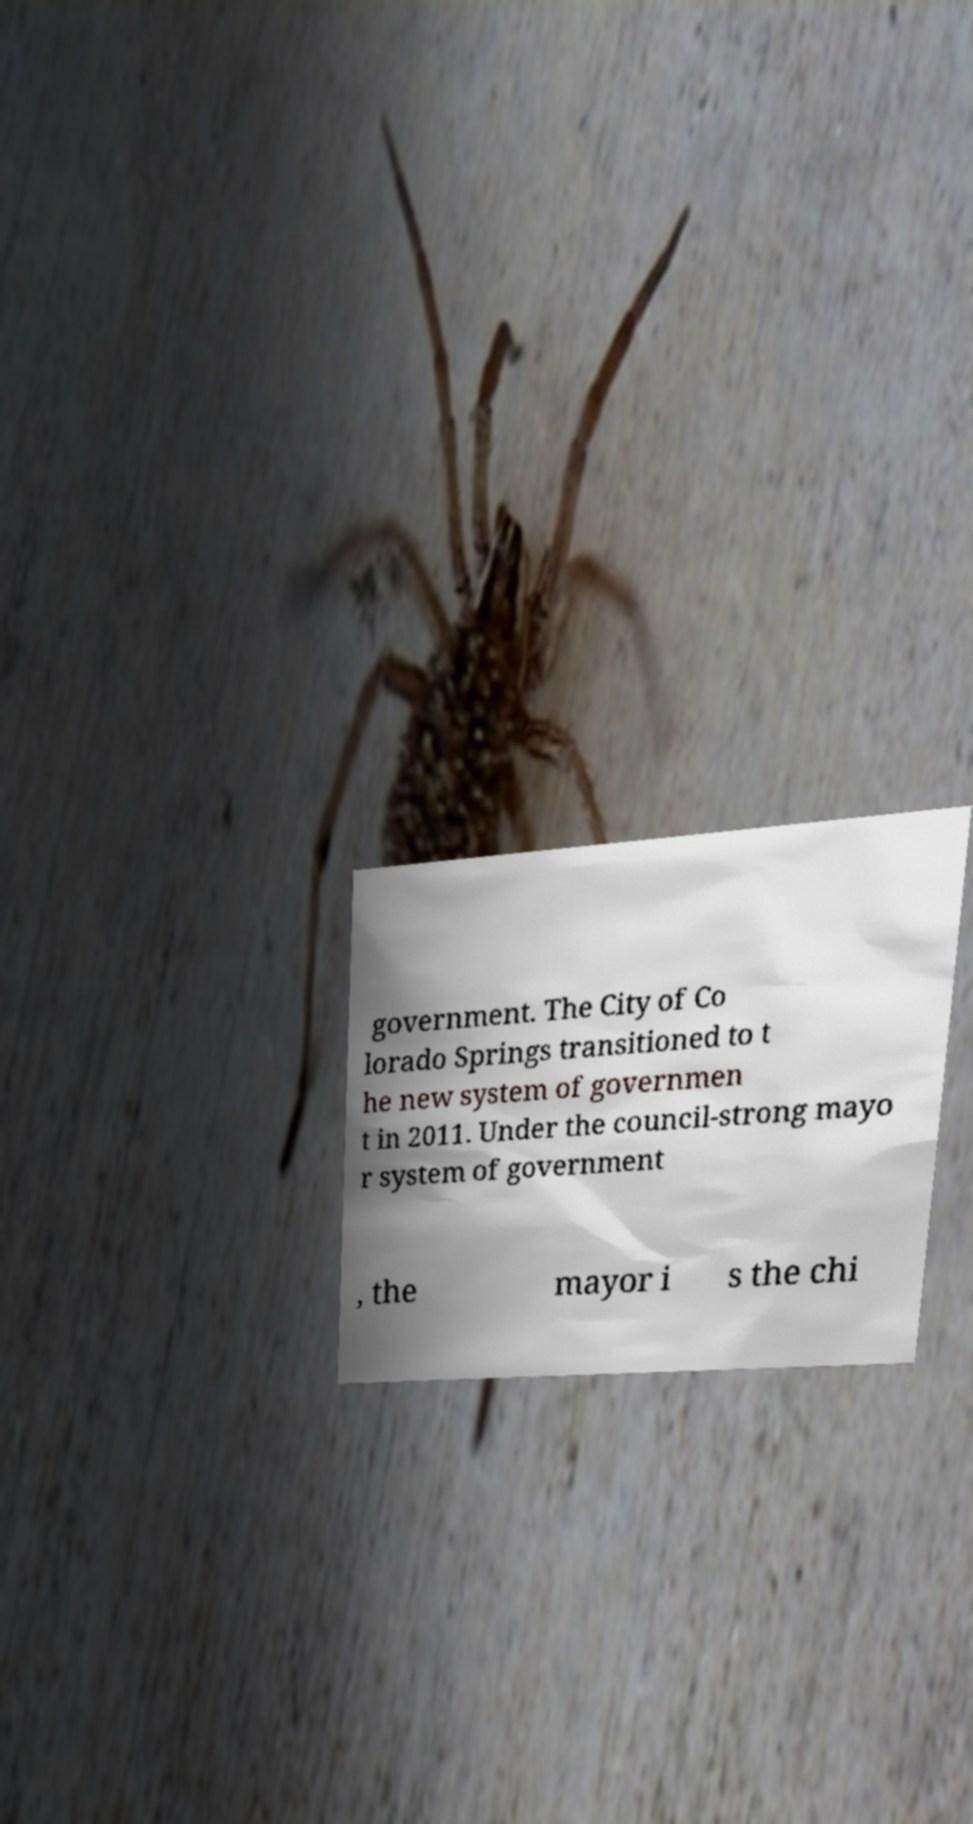There's text embedded in this image that I need extracted. Can you transcribe it verbatim? government. The City of Co lorado Springs transitioned to t he new system of governmen t in 2011. Under the council-strong mayo r system of government , the mayor i s the chi 